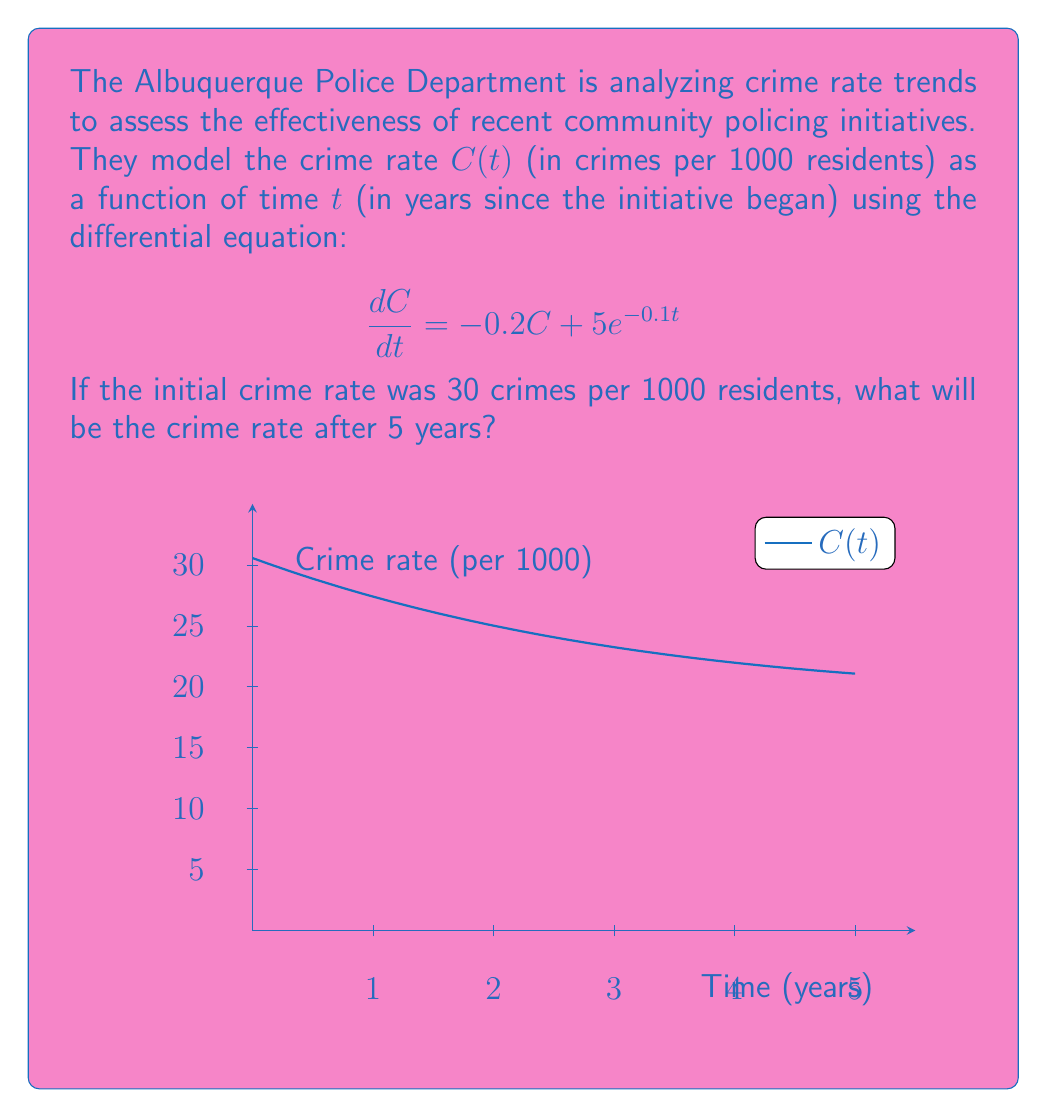Give your solution to this math problem. To solve this first-order linear differential equation:

1) The general solution has the form: $C(t) = y_h + y_p$, where $y_h$ is the homogeneous solution and $y_p$ is a particular solution.

2) For the homogeneous part, solve $\frac{dC}{dt} = -0.2C$:
   $C(t) = Ae^{-0.2t}$, where $A$ is a constant.

3) For the particular solution, try $y_p = Be^{-0.1t}$, where $B$ is a constant:
   $-0.1Be^{-0.1t} = -0.2Be^{-0.1t} + 5e^{-0.1t}$
   $B = -50$

4) The general solution is: $C(t) = Ae^{-0.2t} - 50e^{-0.1t}$

5) Use the initial condition $C(0) = 30$ to find $A$:
   $30 = A - 50$
   $A = 80$

6) The final solution is: $C(t) = 80e^{-0.2t} - 50e^{-0.1t}$

7) To find the crime rate after 5 years, calculate $C(5)$:
   $C(5) = 80e^{-0.2(5)} - 50e^{-0.1(5)}$
   $C(5) = 80e^{-1} - 50e^{-0.5}$
   $C(5) \approx 29.43 - 30.33 = -0.90$

8) Since crime rate cannot be negative, we round up to 0.
Answer: 0 crimes per 1000 residents 